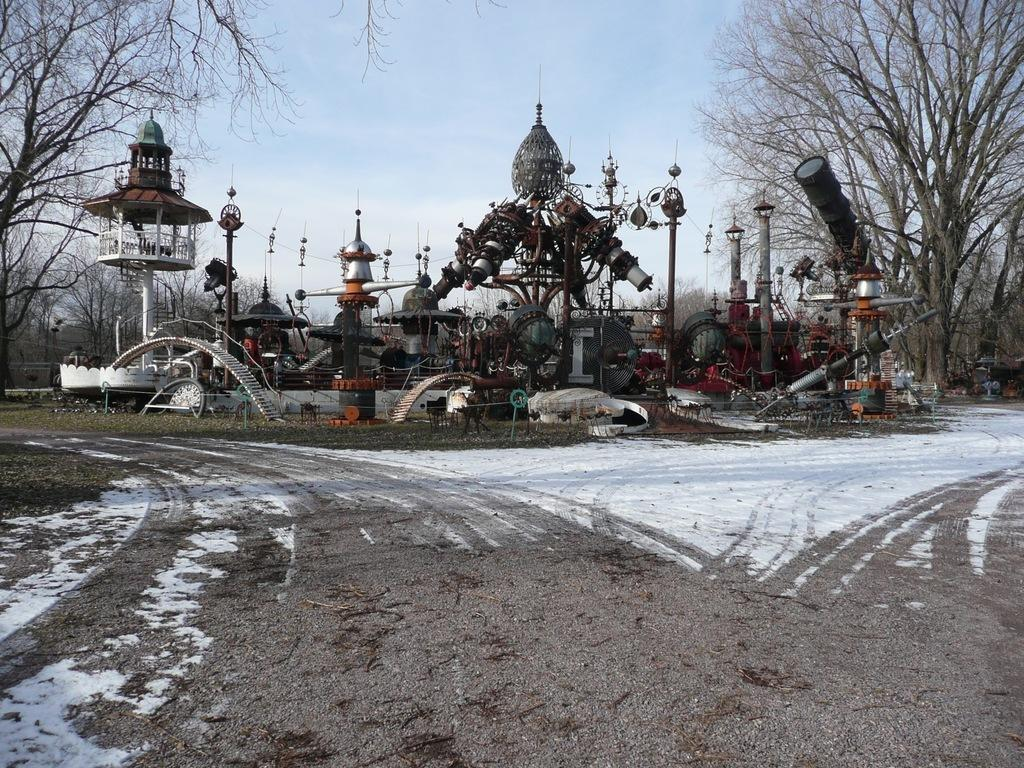What is covering the road at the bottom of the image? There is snow on the road at the bottom of the image. What can be seen in the middle of the image? There are iron structures in the middle of the image. What type of vegetation is present on either side of the image? There are trees on either side of the image. What color is the sky at the top of the image? A: The sky is blue at the top of the image. What type of hat is the snow wearing in the image? There is no hat present in the image, as the snow is not a person or an object that can wear a hat. 